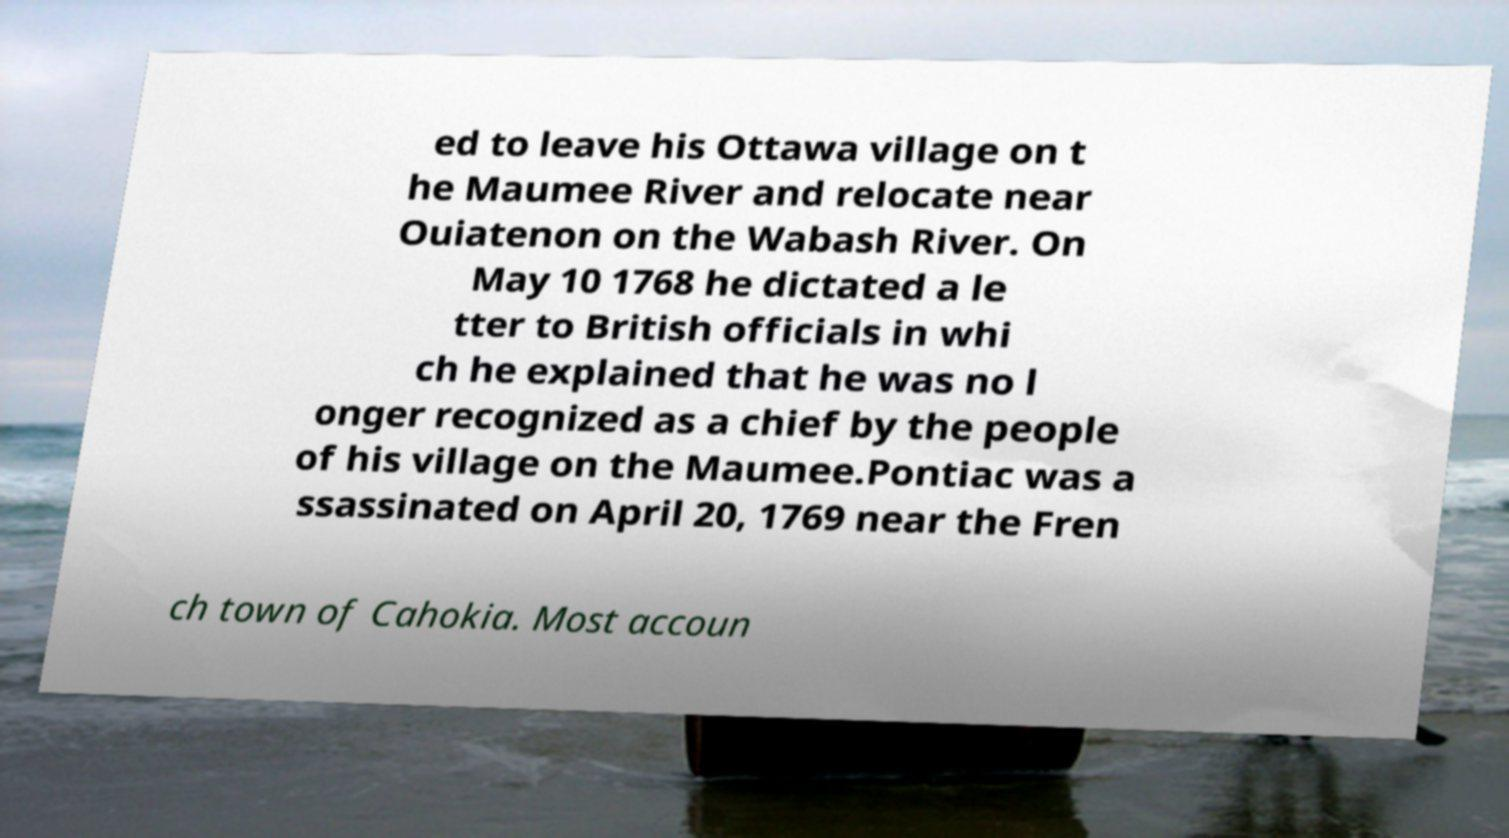I need the written content from this picture converted into text. Can you do that? ed to leave his Ottawa village on t he Maumee River and relocate near Ouiatenon on the Wabash River. On May 10 1768 he dictated a le tter to British officials in whi ch he explained that he was no l onger recognized as a chief by the people of his village on the Maumee.Pontiac was a ssassinated on April 20, 1769 near the Fren ch town of Cahokia. Most accoun 